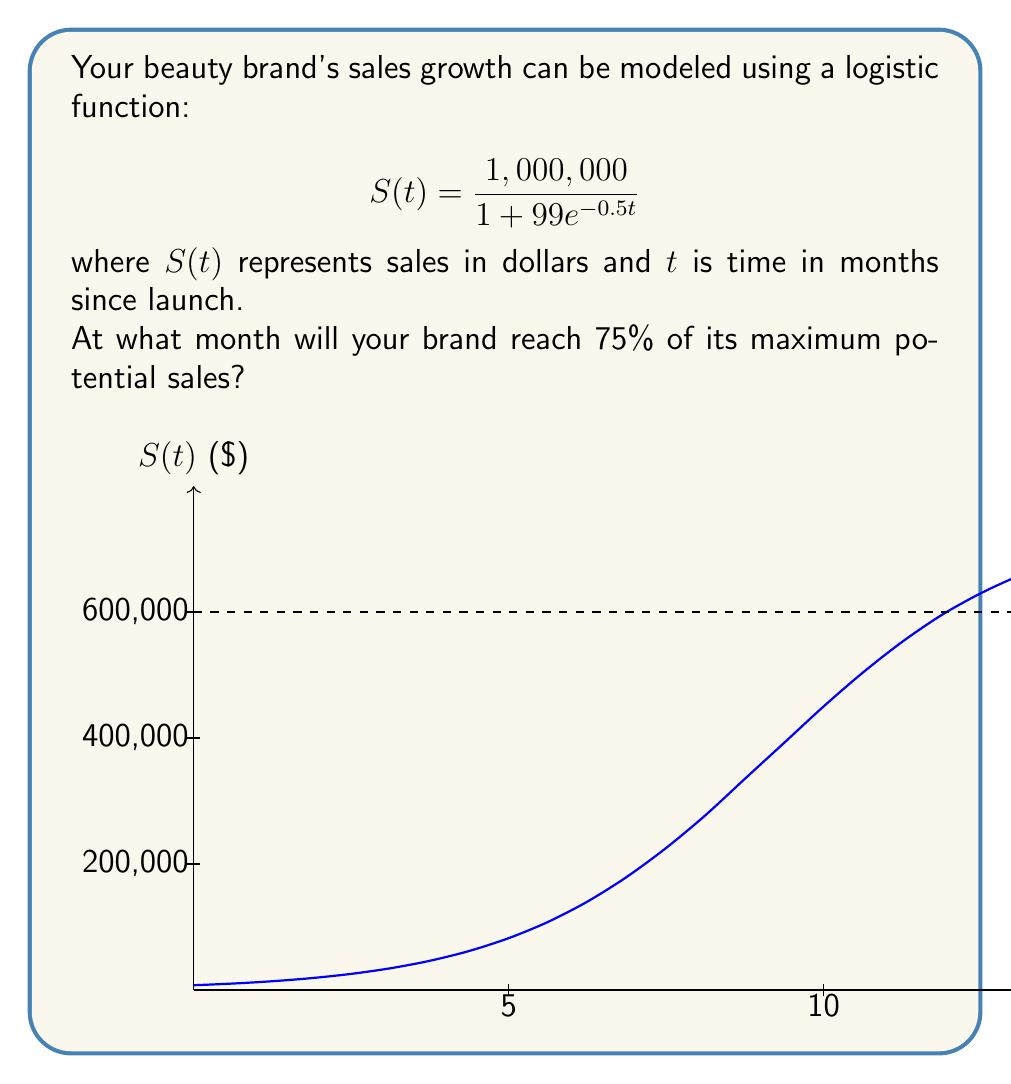Can you solve this math problem? Let's approach this step-by-step:

1) The maximum potential sales is the limit of $S(t)$ as $t$ approaches infinity, which is $1,000,000.

2) We need to find $t$ when $S(t) = 0.75 \times 1,000,000 = 750,000$.

3) Set up the equation:

   $$750,000 = \frac{1,000,000}{1 + 99e^{-0.5t}}$$

4) Multiply both sides by $(1 + 99e^{-0.5t})$:

   $$750,000(1 + 99e^{-0.5t}) = 1,000,000$$

5) Expand:

   $$750,000 + 74,250,000e^{-0.5t} = 1,000,000$$

6) Subtract 750,000 from both sides:

   $$74,250,000e^{-0.5t} = 250,000$$

7) Divide both sides by 74,250,000:

   $$e^{-0.5t} = \frac{1}{297}$$

8) Take the natural log of both sides:

   $$-0.5t = \ln\left(\frac{1}{297}\right) = -\ln(297)$$

9) Divide both sides by -0.5:

   $$t = \frac{\ln(297)}{0.5} \approx 11.37$$

Therefore, the brand will reach 75% of its maximum potential sales after approximately 11.37 months.
Answer: 11.37 months 